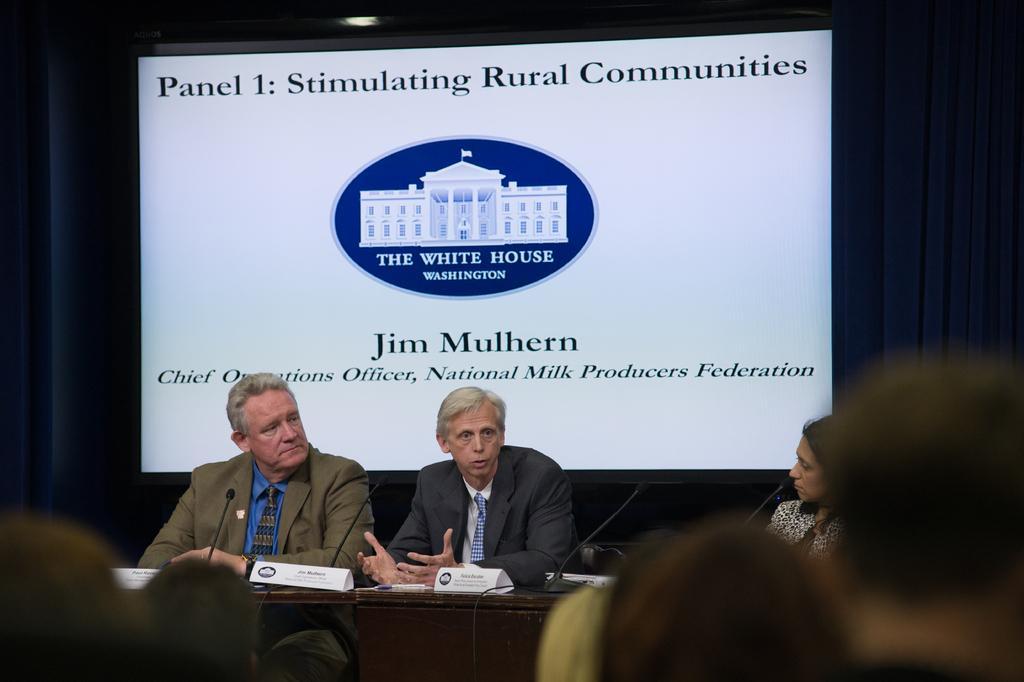Can you describe this image briefly? At the bottom of the image there are few people. There is a table with name boards and mics. Behind the table there are few people sitting. Behind them there is a screen with something written on it. And also there are curtains. 